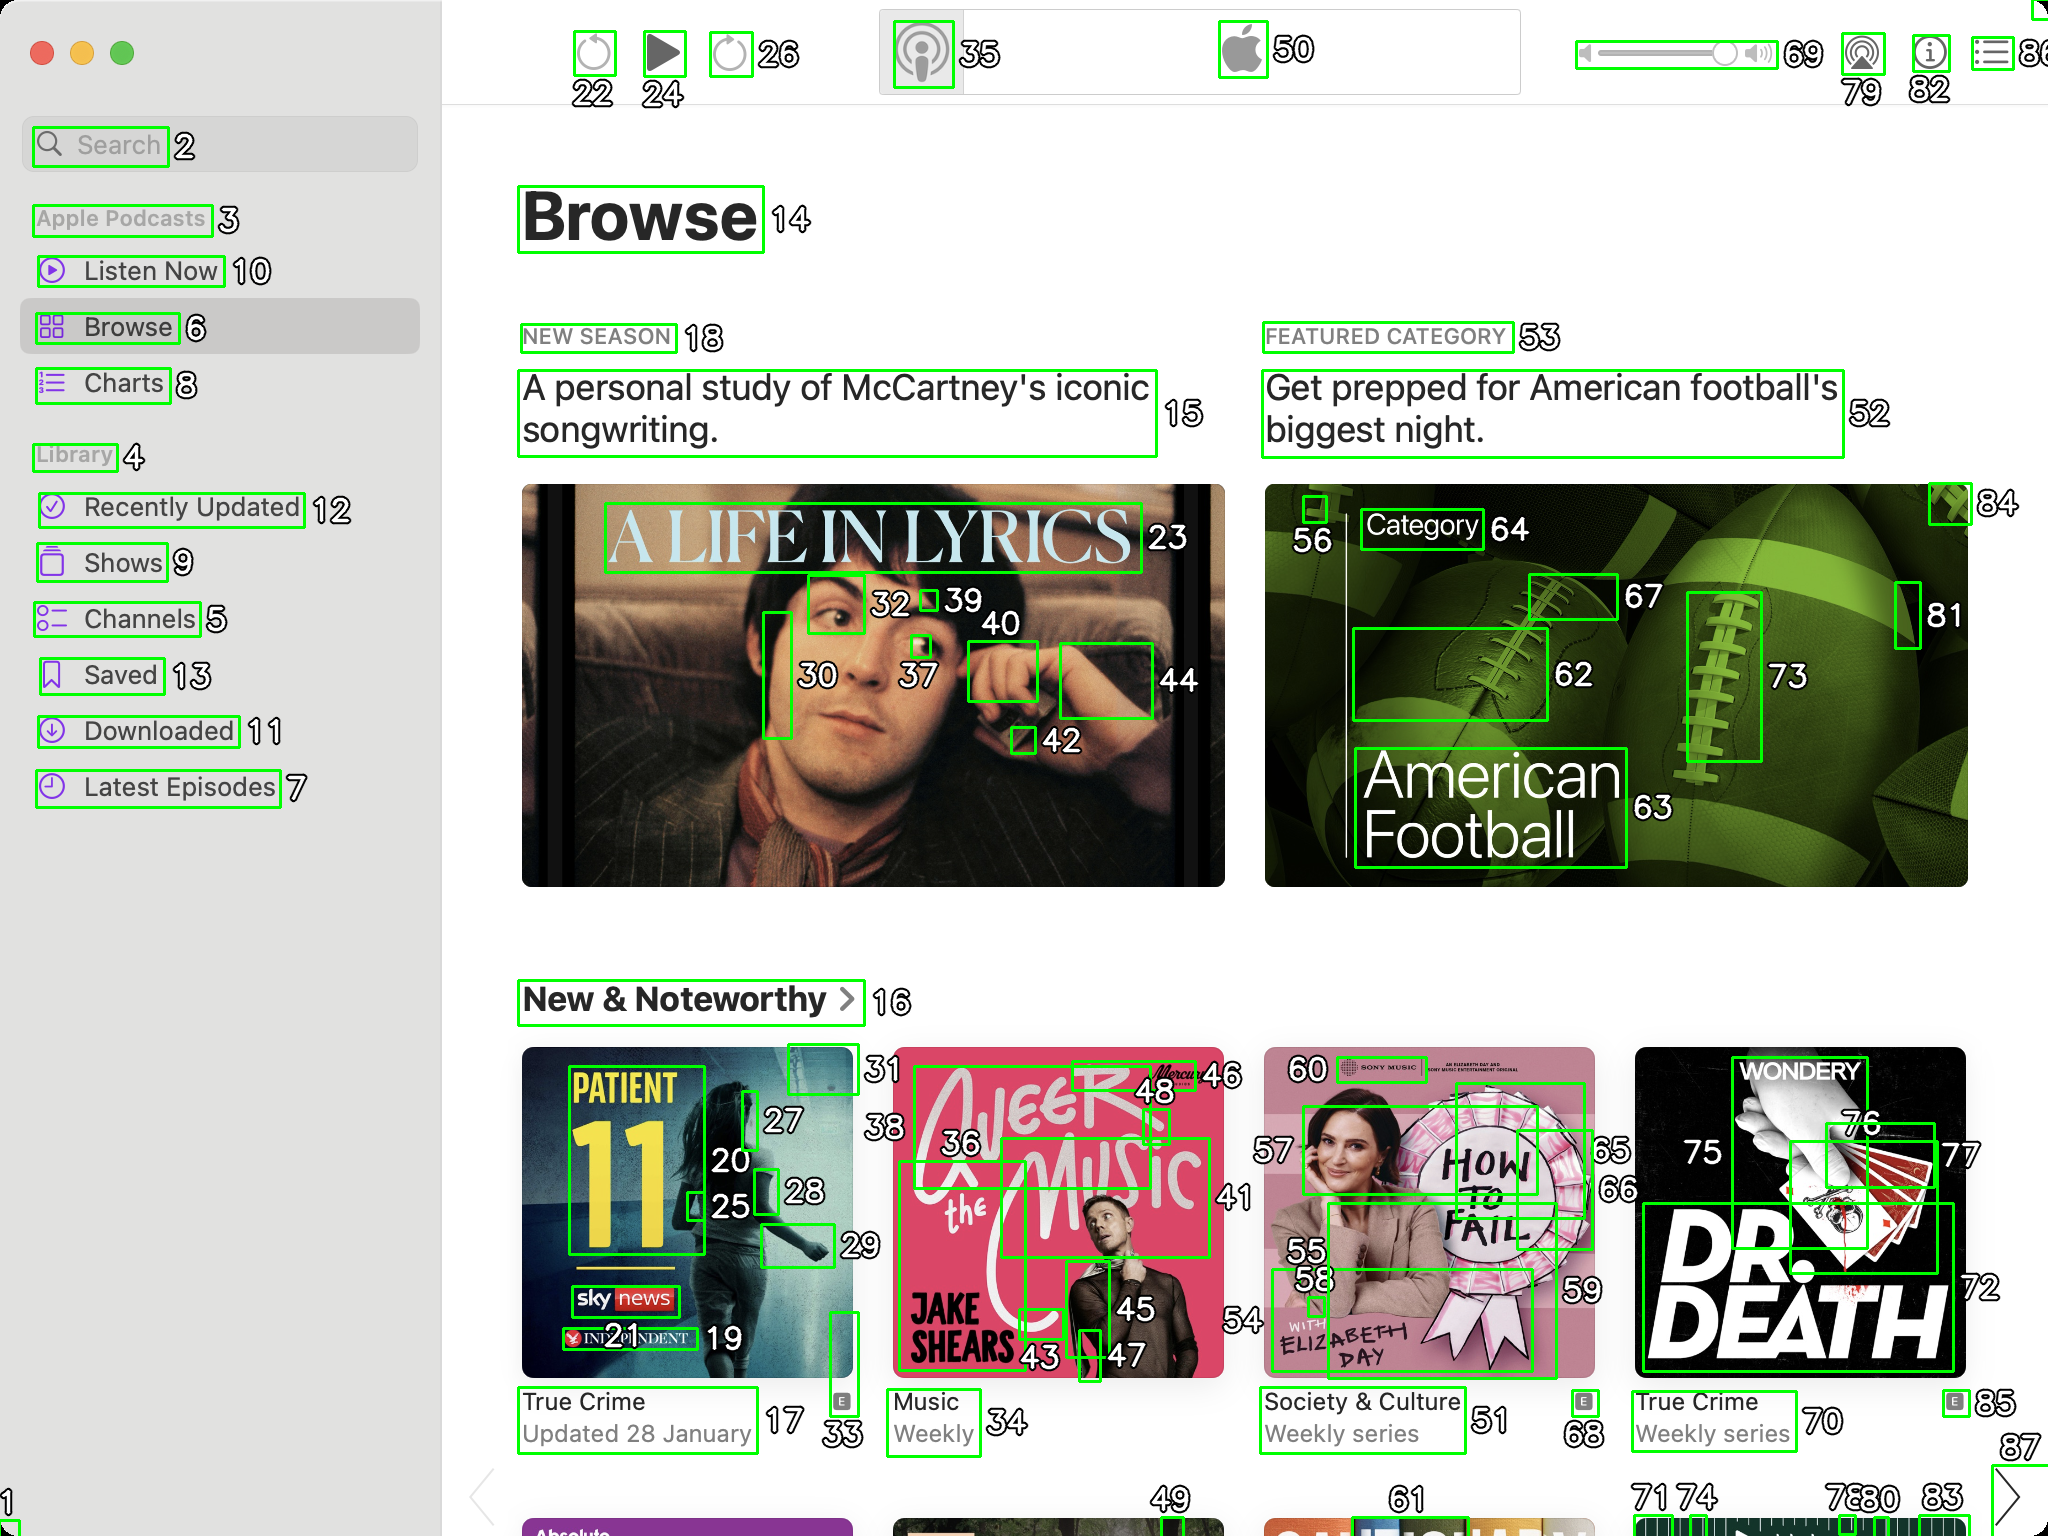You are an AI designed for image processing and segmentation analysis, particularly skilled in merging segmented regions of an image to improve accuracy and readability.

**Task Description:**
Your task is to address a user's concern with a UI screenshot of the Apple Podcasts application on MacOS. The screenshot contains multiple green boxes, each representing a UI element, with a unique white number outlined in black ranging from 1 to 88. Due to segmentation issues, some boxes that belong to the same image are divided unnaturally.

**Objective:**
Merge these segmented areas that correspond to a single UI element to create a coherent representation. The final output should be in JSON format, where each key-value pair represents the merged areas.

**Example JSON Output:**
If boxes with numbers 1, 2, and 3 should belong to the same UI element, the JSON output should be:

```json
{
    "Image A Life In Lyrics": [1, 2, 3]
}
```

If UI element contains only one box than omit that box in final result.

**Instructions:**

- **Identify Segmented Regions:** Analyze the screenshot to identify which green boxes belong to the same UI element.
- **Merge Regions:** Group the numbers of these boxes together to represent a single UI element.
- **Output Format:** Produce the output in JSON format, with each key representing a UI element and each value being a list of the numbers of the merged boxes.

**Primary Objective:**
Ensure the accuracy of the merged regions based on the user's supplied image information, maintaining the integrity and structure of the UI elements in the Apple Podcasts application on MacOS. Based on the provided screenshot, I have identified the segmented regions that belong to the same UI elements. Here is the JSON output representing the merged areas:

```json
{
    "Search": [2],
    "Apple Podcasts": [3],
    "Listen Now": [10],
    "Browse": [6],
    "Charts": [8],
    "Library": [4],
    "Recently Updated": [12],
    "Shows": [9],
    "Channels": [5],
    "Saved": [13],
    "Downloaded": [11],
    "Latest Episodes": [7],
    "A Life In Lyrics": [23, 30, 32, 37, 39, 40, 42, 44],
    "New Season": [18],
    "A personal study of McCartney's iconic songwriting.": [15],
    "Featured Category": [53],
    "Get prepped for American football's biggest night.": [52],
    "American Football": [56, 62, 63, 64, 67, 73, 81, 84],
    "New & Noteworthy": [16],
    "Patient 11": [17, 20, 25, 27, 28, 33],
    "True Crime Updated 28 January": [19],
    "A Beer With The Music": [36, 43, 45, 46, 48],
    "Weekly": [21],
    "How To Fail": [55, 58, 59, 60],
    "Society & Culture Weekly series": [51],
    "Dr. Death": [70, 72, 75, 76, 77],
    "True Crime Weekly series": [85],
    "Apple Logo": [50],
    "Volume Control": [69, 79, 82],
    "Play Button": [24],
    "Pause Button": [26],
    "Forward Button": [22],
    "Backward Button": [35]
}
```

This JSON output groups the segmented boxes into their respective UI elements, ensuring a coherent representation of the Apple Podcasts application UI on MacOS. 